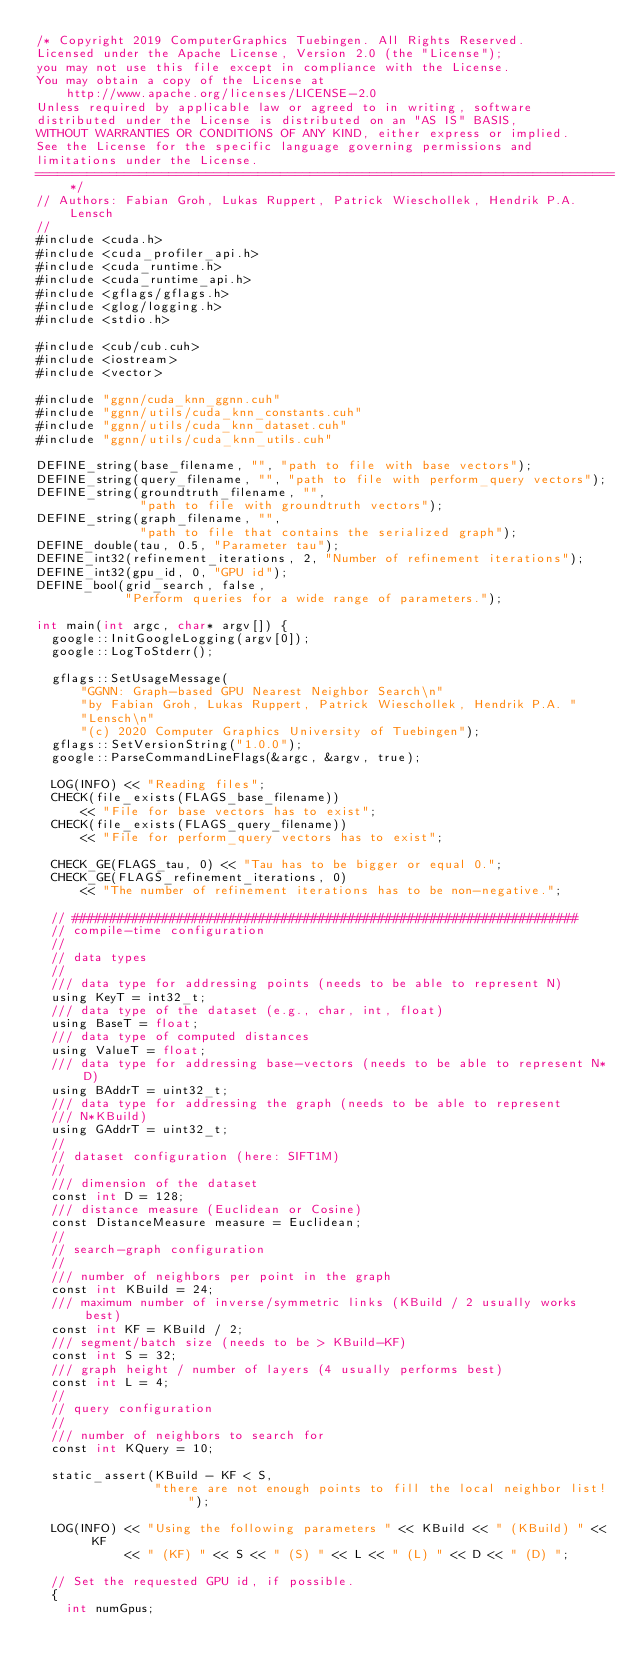Convert code to text. <code><loc_0><loc_0><loc_500><loc_500><_Cuda_>/* Copyright 2019 ComputerGraphics Tuebingen. All Rights Reserved.
Licensed under the Apache License, Version 2.0 (the "License");
you may not use this file except in compliance with the License.
You may obtain a copy of the License at
    http://www.apache.org/licenses/LICENSE-2.0
Unless required by applicable law or agreed to in writing, software
distributed under the License is distributed on an "AS IS" BASIS,
WITHOUT WARRANTIES OR CONDITIONS OF ANY KIND, either express or implied.
See the License for the specific language governing permissions and
limitations under the License.
==============================================================================*/
// Authors: Fabian Groh, Lukas Ruppert, Patrick Wieschollek, Hendrik P.A. Lensch
//
#include <cuda.h>
#include <cuda_profiler_api.h>
#include <cuda_runtime.h>
#include <cuda_runtime_api.h>
#include <gflags/gflags.h>
#include <glog/logging.h>
#include <stdio.h>

#include <cub/cub.cuh>
#include <iostream>
#include <vector>

#include "ggnn/cuda_knn_ggnn.cuh"
#include "ggnn/utils/cuda_knn_constants.cuh"
#include "ggnn/utils/cuda_knn_dataset.cuh"
#include "ggnn/utils/cuda_knn_utils.cuh"

DEFINE_string(base_filename, "", "path to file with base vectors");
DEFINE_string(query_filename, "", "path to file with perform_query vectors");
DEFINE_string(groundtruth_filename, "",
              "path to file with groundtruth vectors");
DEFINE_string(graph_filename, "",
              "path to file that contains the serialized graph");
DEFINE_double(tau, 0.5, "Parameter tau");
DEFINE_int32(refinement_iterations, 2, "Number of refinement iterations");
DEFINE_int32(gpu_id, 0, "GPU id");
DEFINE_bool(grid_search, false,
            "Perform queries for a wide range of parameters.");

int main(int argc, char* argv[]) {
  google::InitGoogleLogging(argv[0]);
  google::LogToStderr();

  gflags::SetUsageMessage(
      "GGNN: Graph-based GPU Nearest Neighbor Search\n"
      "by Fabian Groh, Lukas Ruppert, Patrick Wieschollek, Hendrik P.A. "
      "Lensch\n"
      "(c) 2020 Computer Graphics University of Tuebingen");
  gflags::SetVersionString("1.0.0");
  google::ParseCommandLineFlags(&argc, &argv, true);

  LOG(INFO) << "Reading files";
  CHECK(file_exists(FLAGS_base_filename))
      << "File for base vectors has to exist";
  CHECK(file_exists(FLAGS_query_filename))
      << "File for perform_query vectors has to exist";

  CHECK_GE(FLAGS_tau, 0) << "Tau has to be bigger or equal 0.";
  CHECK_GE(FLAGS_refinement_iterations, 0)
      << "The number of refinement iterations has to be non-negative.";

  // ####################################################################
  // compile-time configuration
  //
  // data types
  //
  /// data type for addressing points (needs to be able to represent N)
  using KeyT = int32_t;
  /// data type of the dataset (e.g., char, int, float)
  using BaseT = float;
  /// data type of computed distances
  using ValueT = float;
  /// data type for addressing base-vectors (needs to be able to represent N*D)
  using BAddrT = uint32_t;
  /// data type for addressing the graph (needs to be able to represent
  /// N*KBuild)
  using GAddrT = uint32_t;
  //
  // dataset configuration (here: SIFT1M)
  //
  /// dimension of the dataset
  const int D = 128;
  /// distance measure (Euclidean or Cosine)
  const DistanceMeasure measure = Euclidean;
  //
  // search-graph configuration
  //
  /// number of neighbors per point in the graph
  const int KBuild = 24;
  /// maximum number of inverse/symmetric links (KBuild / 2 usually works best)
  const int KF = KBuild / 2;
  /// segment/batch size (needs to be > KBuild-KF)
  const int S = 32;
  /// graph height / number of layers (4 usually performs best)
  const int L = 4;
  //
  // query configuration
  //
  /// number of neighbors to search for
  const int KQuery = 10;

  static_assert(KBuild - KF < S,
                "there are not enough points to fill the local neighbor list!");

  LOG(INFO) << "Using the following parameters " << KBuild << " (KBuild) " << KF
            << " (KF) " << S << " (S) " << L << " (L) " << D << " (D) ";

  // Set the requested GPU id, if possible.
  {
    int numGpus;</code> 